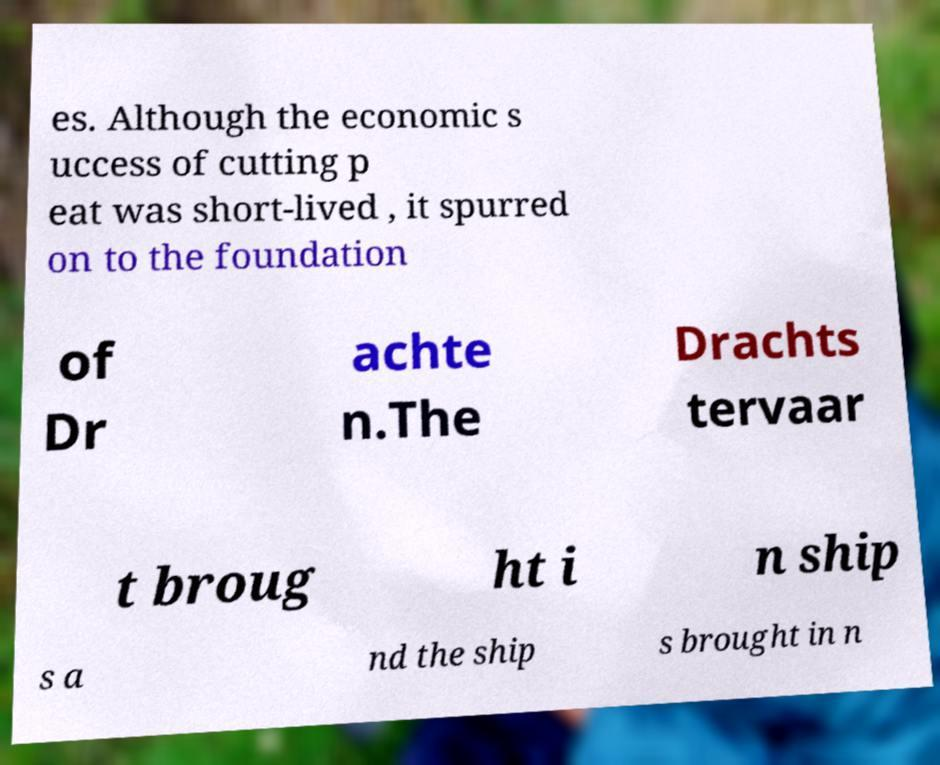For documentation purposes, I need the text within this image transcribed. Could you provide that? es. Although the economic s uccess of cutting p eat was short-lived , it spurred on to the foundation of Dr achte n.The Drachts tervaar t broug ht i n ship s a nd the ship s brought in n 